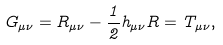<formula> <loc_0><loc_0><loc_500><loc_500>G _ { \mu \nu } = R _ { \mu \nu } - \frac { 1 } { 2 } h _ { \mu \nu } R = T _ { \mu \nu } ,</formula> 